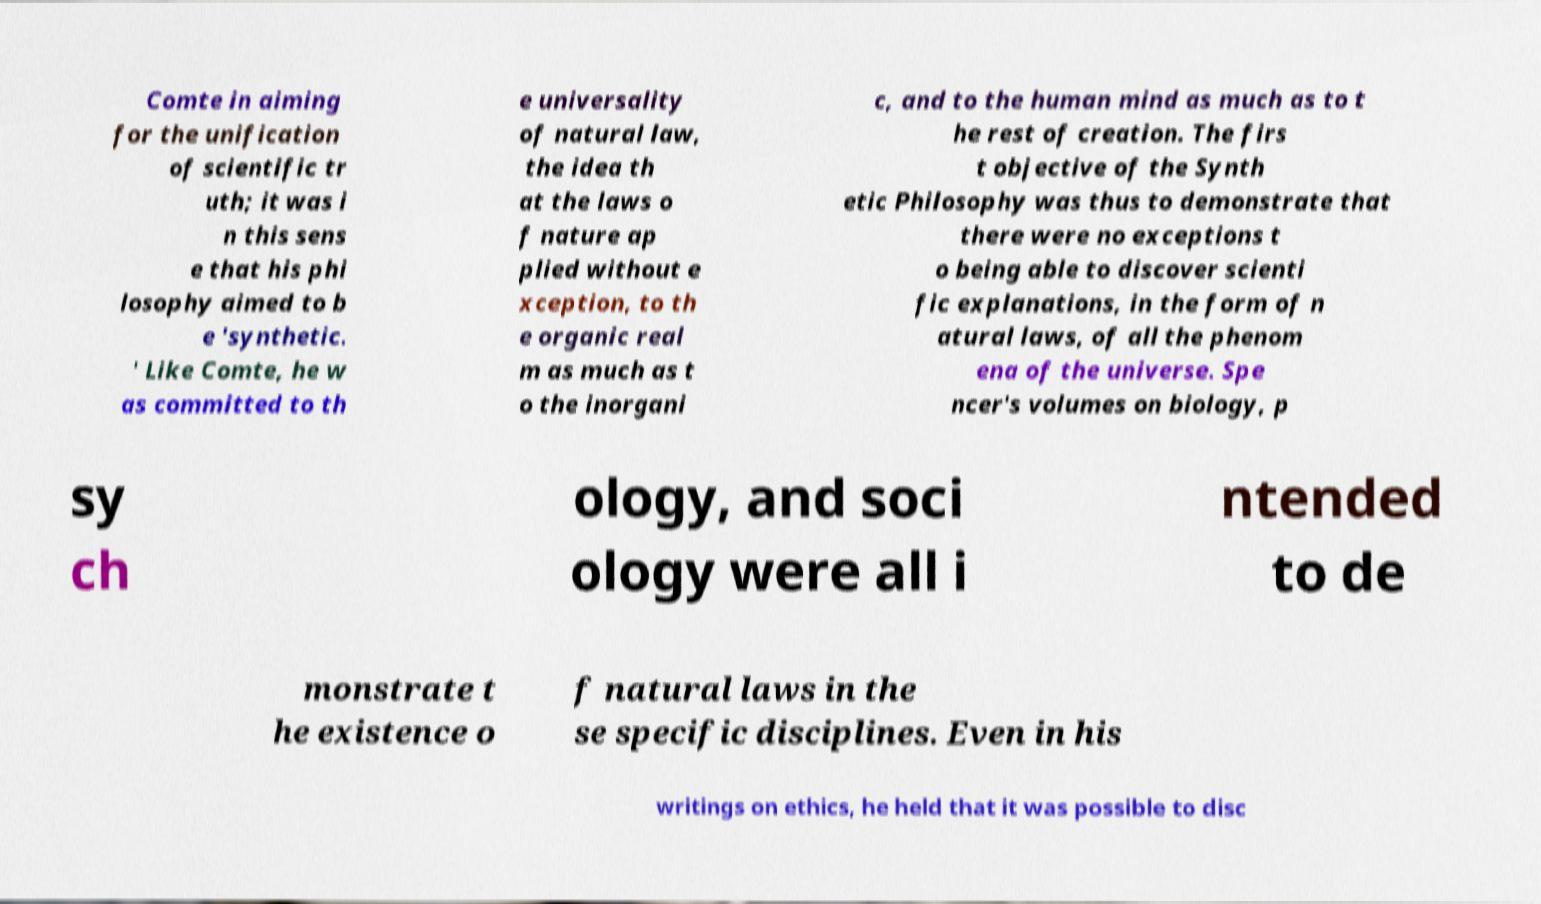What messages or text are displayed in this image? I need them in a readable, typed format. Comte in aiming for the unification of scientific tr uth; it was i n this sens e that his phi losophy aimed to b e 'synthetic. ' Like Comte, he w as committed to th e universality of natural law, the idea th at the laws o f nature ap plied without e xception, to th e organic real m as much as t o the inorgani c, and to the human mind as much as to t he rest of creation. The firs t objective of the Synth etic Philosophy was thus to demonstrate that there were no exceptions t o being able to discover scienti fic explanations, in the form of n atural laws, of all the phenom ena of the universe. Spe ncer's volumes on biology, p sy ch ology, and soci ology were all i ntended to de monstrate t he existence o f natural laws in the se specific disciplines. Even in his writings on ethics, he held that it was possible to disc 